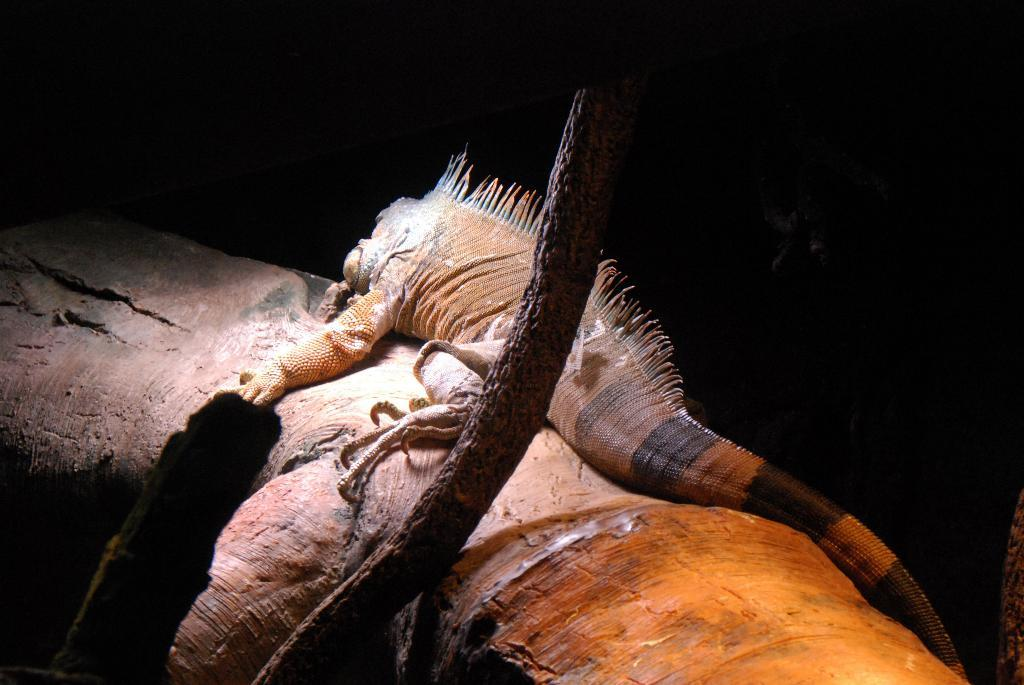What type of animal is in the image? There is a reptile in the image. What is the reptile resting on? The reptile is on an object. What type of vegetation is visible at the bottom of the image? There are branches at the bottom of the image. What can be observed about the lighting in the image? The background of the image is dark. What type of book is the reptile reading in the image? There is no book present in the image, and the reptile is not shown reading. What color is the paint on the branches in the image? There is no paint visible on the branches in the image; they appear to be their natural color. 